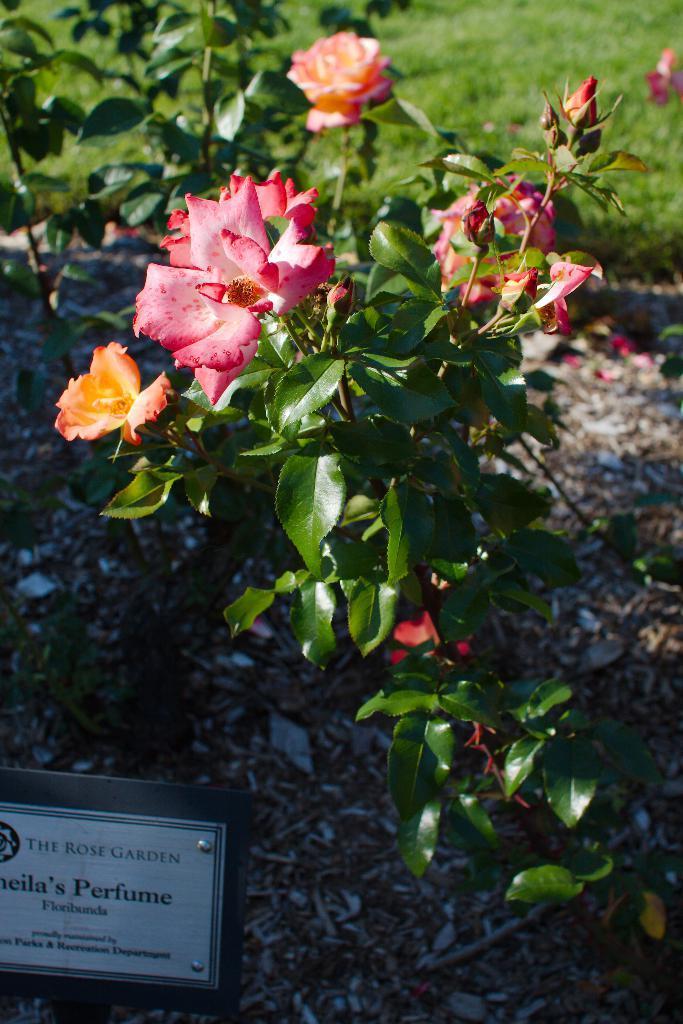In one or two sentences, can you explain what this image depicts? In this image there are rose plants, in the bottom left there is a board, on that board there is some text. 